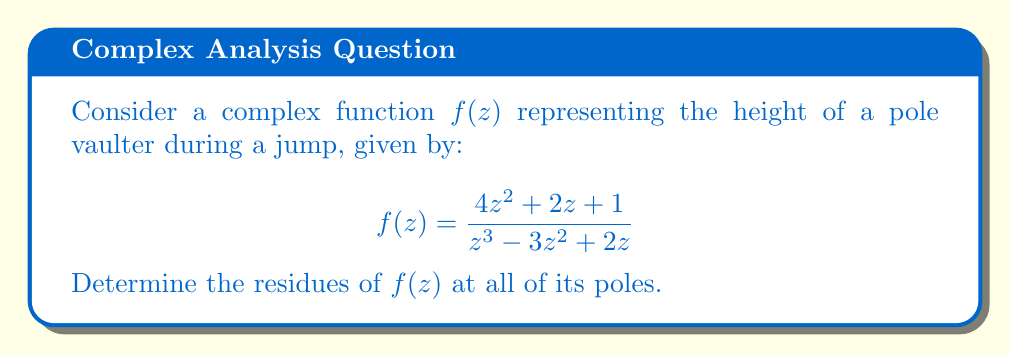What is the answer to this math problem? To find the residues of $f(z)$, we need to:
1. Identify the poles of the function
2. Determine the order of each pole
3. Calculate the residue at each pole

Step 1: Identify the poles
The poles are the roots of the denominator: $z^3 - 3z^2 + 2z = z(z^2 - 3z + 2) = z(z-1)(z-2)$
So, the poles are at $z = 0$, $z = 1$, and $z = 2$.

Step 2: Determine the order of each pole
All poles are simple (order 1) as they appear only once in the factorization.

Step 3: Calculate the residues

For simple poles, we can use the formula:
$$\text{Res}(f,a) = \lim_{z \to a} (z-a)f(z)$$

At $z = 0$:
$$\text{Res}(f,0) = \lim_{z \to 0} z \cdot \frac{4z^2 + 2z + 1}{z^3 - 3z^2 + 2z} = \lim_{z \to 0} \frac{4z^2 + 2z + 1}{z^2 - 3z + 2} = \frac{1}{2}$$

At $z = 1$:
$$\text{Res}(f,1) = \lim_{z \to 1} (z-1) \cdot \frac{4z^2 + 2z + 1}{z^3 - 3z^2 + 2z} = \frac{4(1)^2 + 2(1) + 1}{3(1)^2 - 6(1) + 2} = \frac{7}{-1} = -7$$

At $z = 2$:
$$\text{Res}(f,2) = \lim_{z \to 2} (z-2) \cdot \frac{4z^2 + 2z + 1}{z^3 - 3z^2 + 2z} = \frac{4(2)^2 + 2(2) + 1}{3(2)^2 - 6(2) + 2} = \frac{21}{6} = \frac{7}{2}$$
Answer: The residues of $f(z)$ are:
$\text{Res}(f,0) = \frac{1}{2}$
$\text{Res}(f,1) = -7$
$\text{Res}(f,2) = \frac{7}{2}$ 